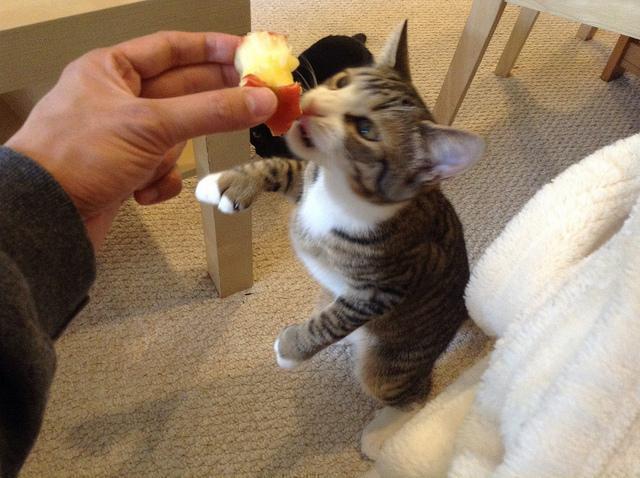How many apples are there?
Give a very brief answer. 1. How many bears are seen to the left of the tree?
Give a very brief answer. 0. 